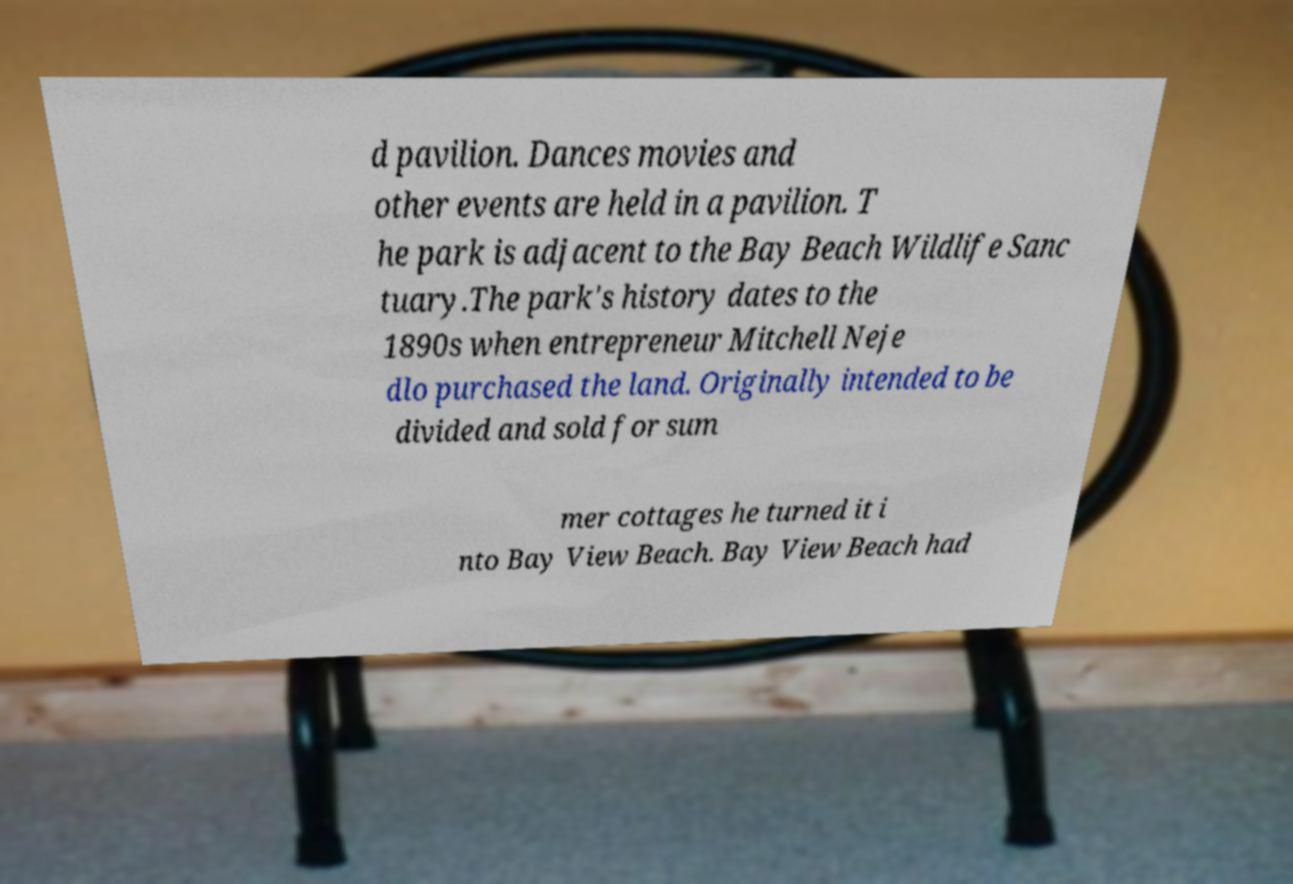Please read and relay the text visible in this image. What does it say? d pavilion. Dances movies and other events are held in a pavilion. T he park is adjacent to the Bay Beach Wildlife Sanc tuary.The park's history dates to the 1890s when entrepreneur Mitchell Neje dlo purchased the land. Originally intended to be divided and sold for sum mer cottages he turned it i nto Bay View Beach. Bay View Beach had 